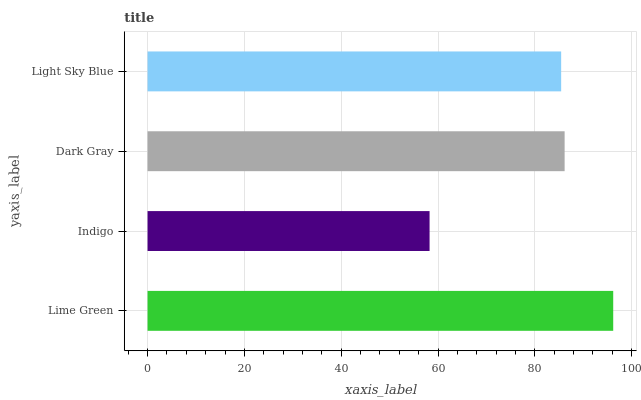Is Indigo the minimum?
Answer yes or no. Yes. Is Lime Green the maximum?
Answer yes or no. Yes. Is Dark Gray the minimum?
Answer yes or no. No. Is Dark Gray the maximum?
Answer yes or no. No. Is Dark Gray greater than Indigo?
Answer yes or no. Yes. Is Indigo less than Dark Gray?
Answer yes or no. Yes. Is Indigo greater than Dark Gray?
Answer yes or no. No. Is Dark Gray less than Indigo?
Answer yes or no. No. Is Dark Gray the high median?
Answer yes or no. Yes. Is Light Sky Blue the low median?
Answer yes or no. Yes. Is Light Sky Blue the high median?
Answer yes or no. No. Is Indigo the low median?
Answer yes or no. No. 